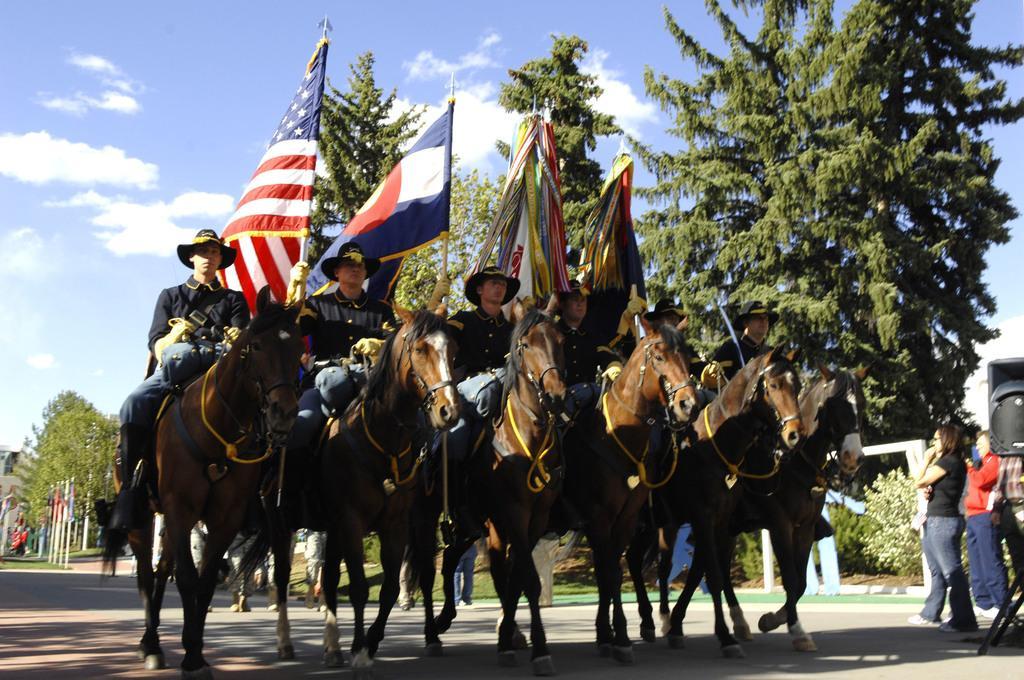Describe this image in one or two sentences. In the foreground of the picture we can see people, flags, horses and road. In the middle of the picture we can see trees, flags and various objects. At the top there is sky. 